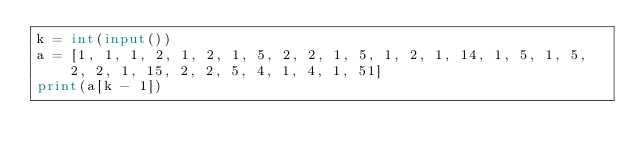Convert code to text. <code><loc_0><loc_0><loc_500><loc_500><_Python_>k = int(input())
a = [1, 1, 1, 2, 1, 2, 1, 5, 2, 2, 1, 5, 1, 2, 1, 14, 1, 5, 1, 5, 2, 2, 1, 15, 2, 2, 5, 4, 1, 4, 1, 51]
print(a[k - 1])</code> 